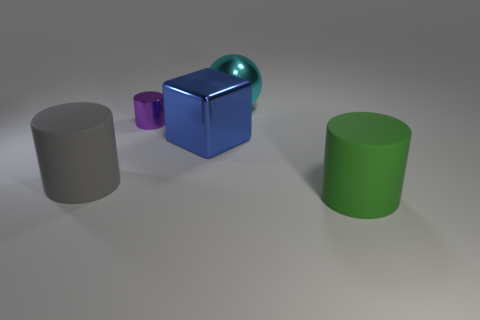There is a rubber thing that is on the left side of the rubber thing in front of the rubber object that is behind the large green rubber object; what is its shape?
Offer a terse response. Cylinder. What is the thing that is behind the large blue thing and in front of the large cyan metallic thing made of?
Give a very brief answer. Metal. There is a large matte object that is in front of the large rubber object that is behind the green cylinder; what shape is it?
Give a very brief answer. Cylinder. Is there any other thing that is the same color as the metal cube?
Ensure brevity in your answer.  No. There is a shiny sphere; does it have the same size as the matte thing to the left of the large block?
Provide a succinct answer. Yes. What number of big things are red spheres or gray rubber objects?
Offer a very short reply. 1. Are there more tiny green rubber cubes than big cylinders?
Give a very brief answer. No. There is a large cylinder that is right of the gray matte object that is on the left side of the cyan thing; how many large cyan things are in front of it?
Ensure brevity in your answer.  0. The gray object has what shape?
Give a very brief answer. Cylinder. How many other objects are there of the same material as the block?
Offer a very short reply. 2. 